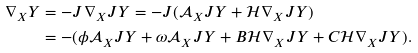Convert formula to latex. <formula><loc_0><loc_0><loc_500><loc_500>\nabla _ { X } Y & = - J \nabla _ { X } J Y = - J ( \mathcal { A } _ { X } J Y + \mathcal { H } \nabla _ { X } J Y ) \\ & = - ( \phi \mathcal { A } _ { X } J Y + \omega \mathcal { A } _ { X } J Y + B \mathcal { H } \nabla _ { X } J Y + C \mathcal { H } \nabla _ { X } J Y ) .</formula> 